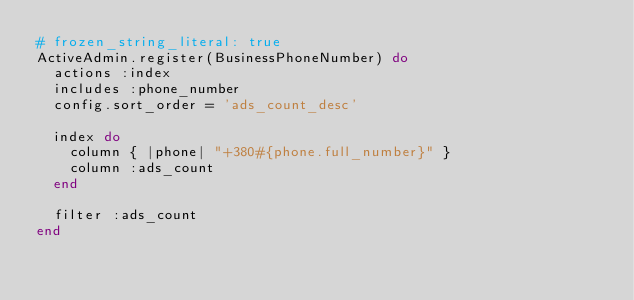<code> <loc_0><loc_0><loc_500><loc_500><_Ruby_># frozen_string_literal: true
ActiveAdmin.register(BusinessPhoneNumber) do
  actions :index
  includes :phone_number
  config.sort_order = 'ads_count_desc'

  index do
    column { |phone| "+380#{phone.full_number}" }
    column :ads_count
  end

  filter :ads_count
end
</code> 